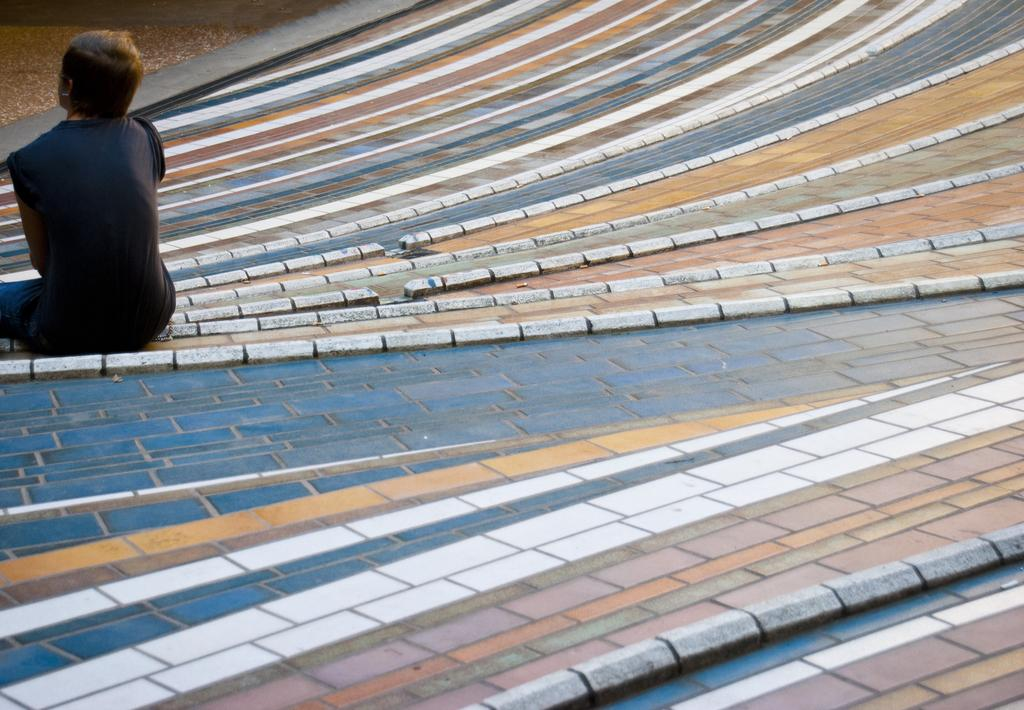Who or what is the main subject in the image? There is a person in the image. What is the person doing in the image? The person is sitting on the floor. Can you describe the floor in the image? The floor has colorful patterns. What is the person wearing in the image? The person is wearing a black top. What type of plant is growing on the person's head in the image? There is no plant growing on the person's head in the image. What color is the paint used for the patterns on the floor? The provided facts do not mention any paint or its color; they only mention the colorful patterns on the floor. 